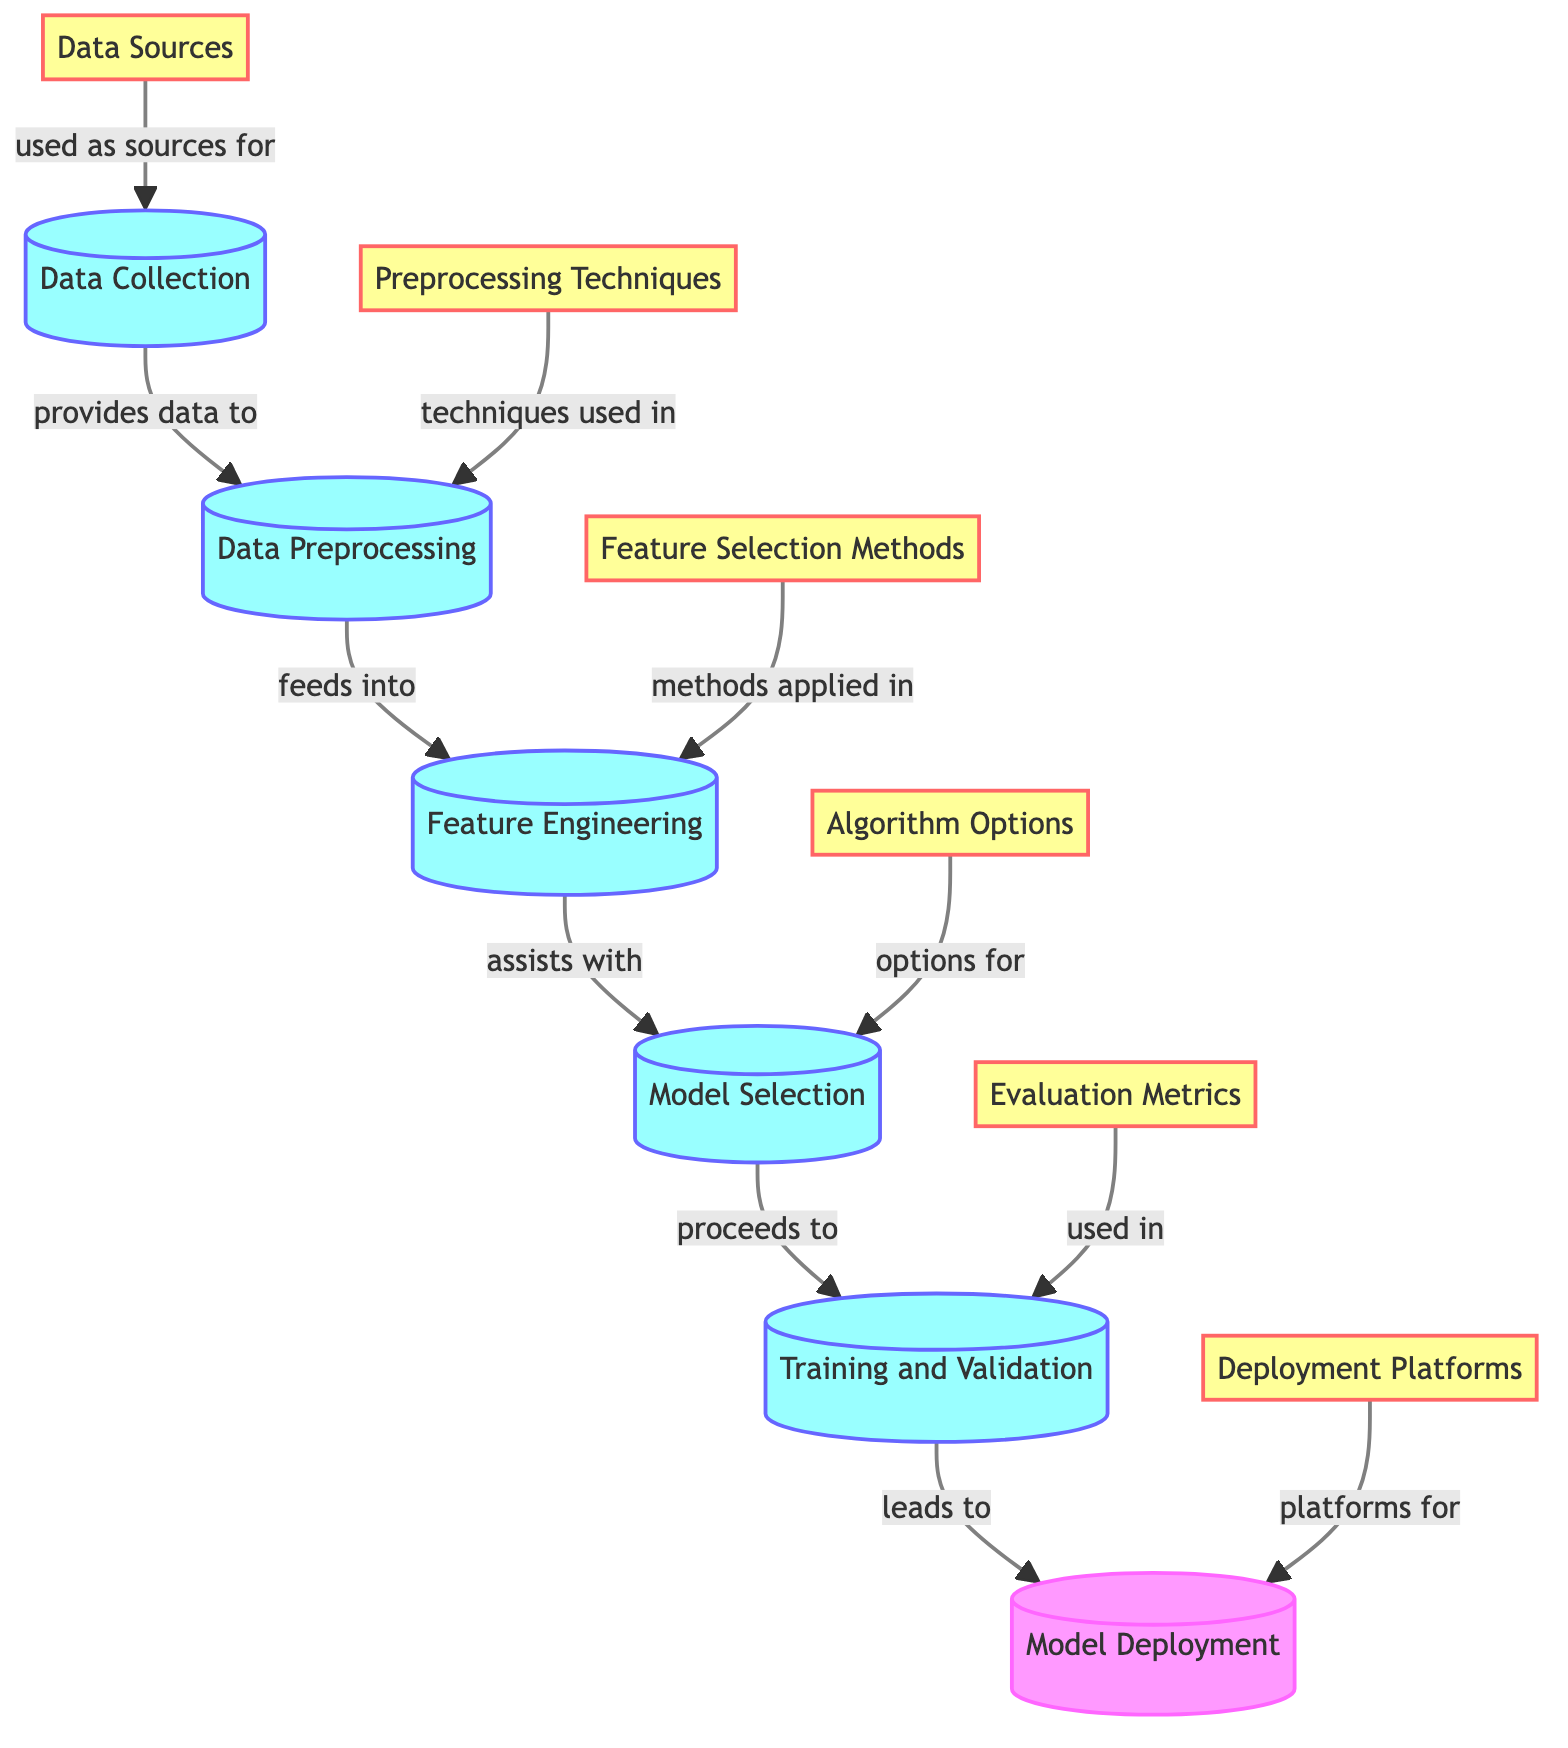What is the first step in the diagram? The first step in the diagram is "Data Collection," which is represented as the first process node.
Answer: Data Collection How many source nodes are there in the diagram? There are six source nodes in the diagram identified as data sources for different stages.
Answer: Six What process follows Data Preprocessing? The process that follows Data Preprocessing is "Feature Engineering," which is directly linked from the Data Preprocessing node.
Answer: Feature Engineering Which nodes provide techniques used in Data Preprocessing? The "Preprocessing Techniques" node is the one that directly provides techniques used in Data Preprocessing, as denoted by the connecting edge in the diagram.
Answer: Preprocessing Techniques What are the options for Model Selection? The options for Model Selection come from the "Algorithm Options" node, which indicates the different algorithms available for selection during this process.
Answer: Algorithm Options What is the last step before Model Deployment? The last step before Model Deployment is "Training and Validation," which is the final process leading into the deployment phase in the diagram.
Answer: Training and Validation What metric is used in the Training and Validation stage? The metric used in this stage is specified in the "Evaluation Metrics" node, which is connected as a source for evaluating model performance.
Answer: Evaluation Metrics What source directly feeds the Model Selection process? The source that directly feeds into the Model Selection process is the "Algorithm Options," as shown by the connecting edge leading from this source.
Answer: Algorithm Options Which platform is indicated for Model Deployment? The platforms for Model Deployment are enumerated in the "Deployment Platforms" node, which indicates where the model will be deployed.
Answer: Deployment Platforms 